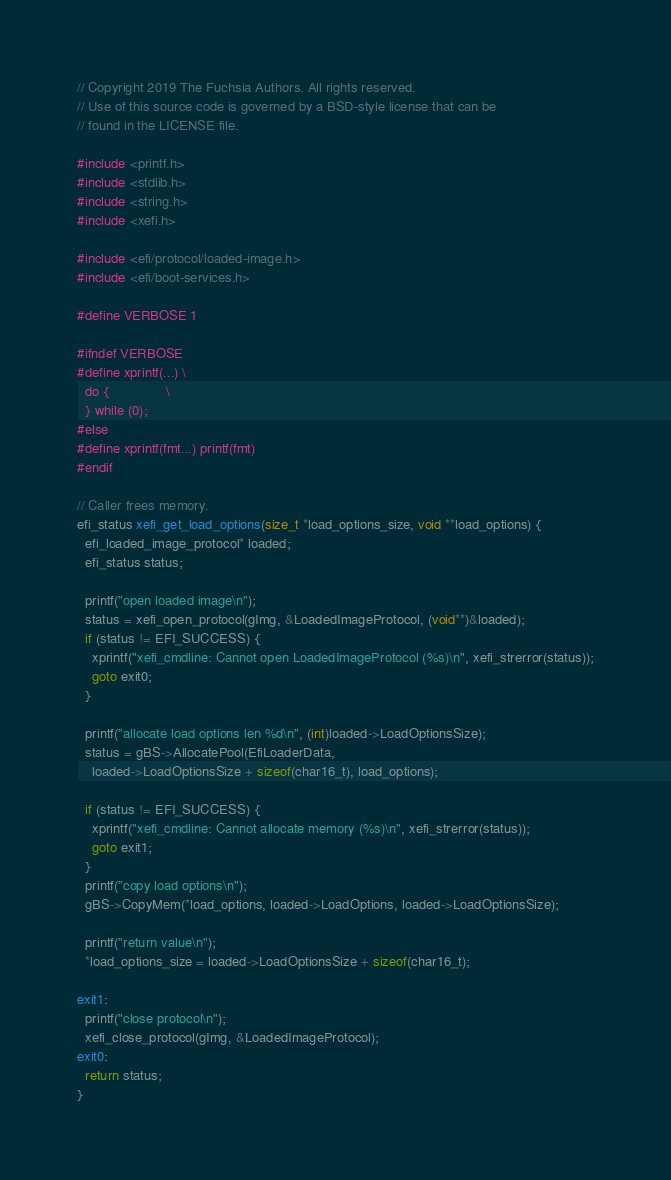Convert code to text. <code><loc_0><loc_0><loc_500><loc_500><_C_>// Copyright 2019 The Fuchsia Authors. All rights reserved.
// Use of this source code is governed by a BSD-style license that can be
// found in the LICENSE file.

#include <printf.h>
#include <stdlib.h>
#include <string.h>
#include <xefi.h>

#include <efi/protocol/loaded-image.h>
#include <efi/boot-services.h>

#define VERBOSE 1

#ifndef VERBOSE
#define xprintf(...) \
  do {               \
  } while (0);
#else
#define xprintf(fmt...) printf(fmt)
#endif

// Caller frees memory.
efi_status xefi_get_load_options(size_t *load_options_size, void **load_options) {
  efi_loaded_image_protocol* loaded;
  efi_status status;

  printf("open loaded image\n");
  status = xefi_open_protocol(gImg, &LoadedImageProtocol, (void**)&loaded);
  if (status != EFI_SUCCESS) {
    xprintf("xefi_cmdline: Cannot open LoadedImageProtocol (%s)\n", xefi_strerror(status));
    goto exit0;
  }

  printf("allocate load options len %d\n", (int)loaded->LoadOptionsSize);
  status = gBS->AllocatePool(EfiLoaderData,
    loaded->LoadOptionsSize + sizeof(char16_t), load_options);

  if (status != EFI_SUCCESS) {
    xprintf("xefi_cmdline: Cannot allocate memory (%s)\n", xefi_strerror(status));
    goto exit1;
  }
  printf("copy load options\n");
  gBS->CopyMem(*load_options, loaded->LoadOptions, loaded->LoadOptionsSize);

  printf("return value\n");
  *load_options_size = loaded->LoadOptionsSize + sizeof(char16_t);

exit1:
  printf("close protocol\n");
  xefi_close_protocol(gImg, &LoadedImageProtocol);
exit0:
  return status;
}
</code> 